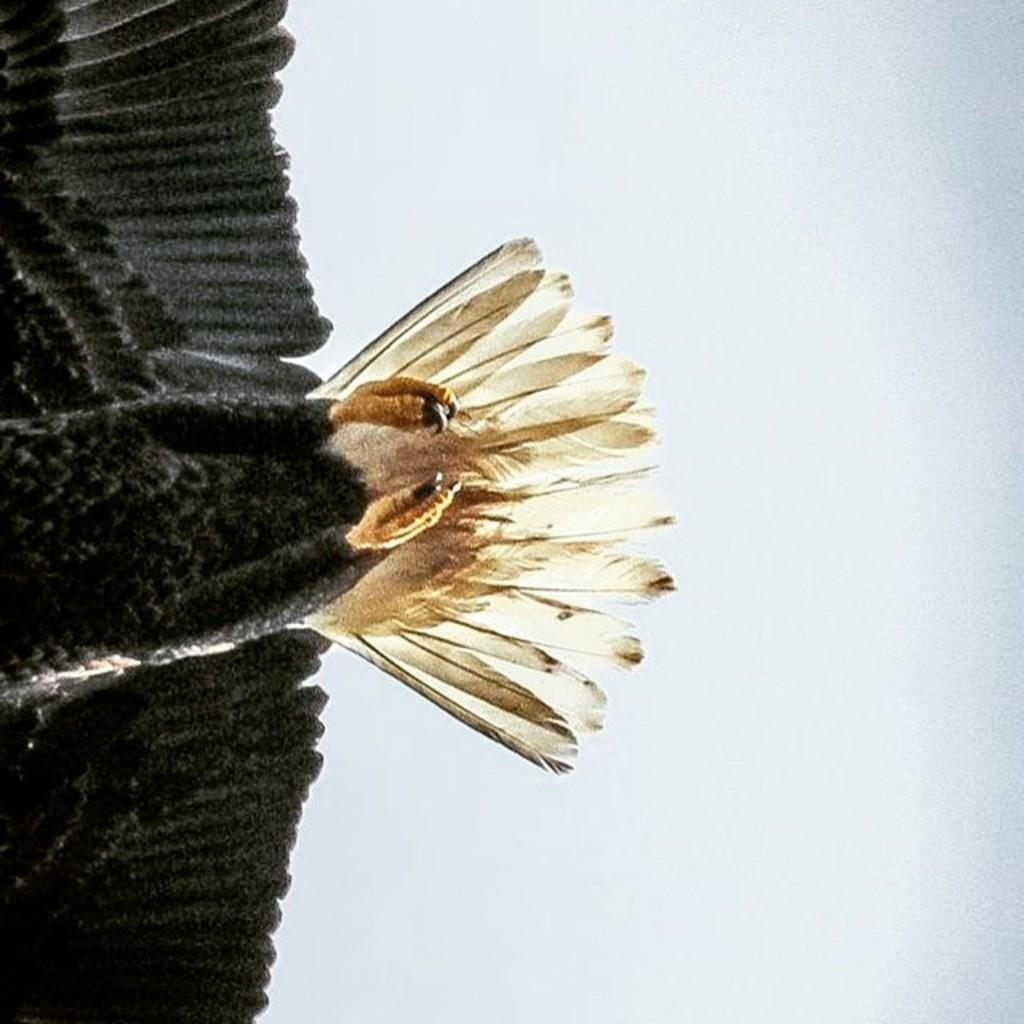What type of animal is in the image? There is a bird in the image. What parts of the bird can be seen in the image? The bird's legs and wings are visible in the image. What is visible in the background of the image? There is sky visible in the image. Can you tell me how the bear is related to the bird in the image? There is no bear present in the image, so it is not possible to determine any relationship between a bear and the bird. 